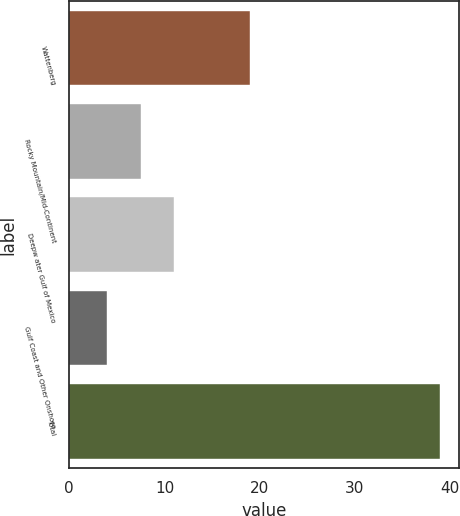<chart> <loc_0><loc_0><loc_500><loc_500><bar_chart><fcel>Wattenberg<fcel>Rocky Mountain/Mid-Continent<fcel>Deepw ater Gulf of Mexico<fcel>Gulf Coast and Other Onshore<fcel>Total<nl><fcel>19<fcel>7.5<fcel>11<fcel>4<fcel>39<nl></chart> 